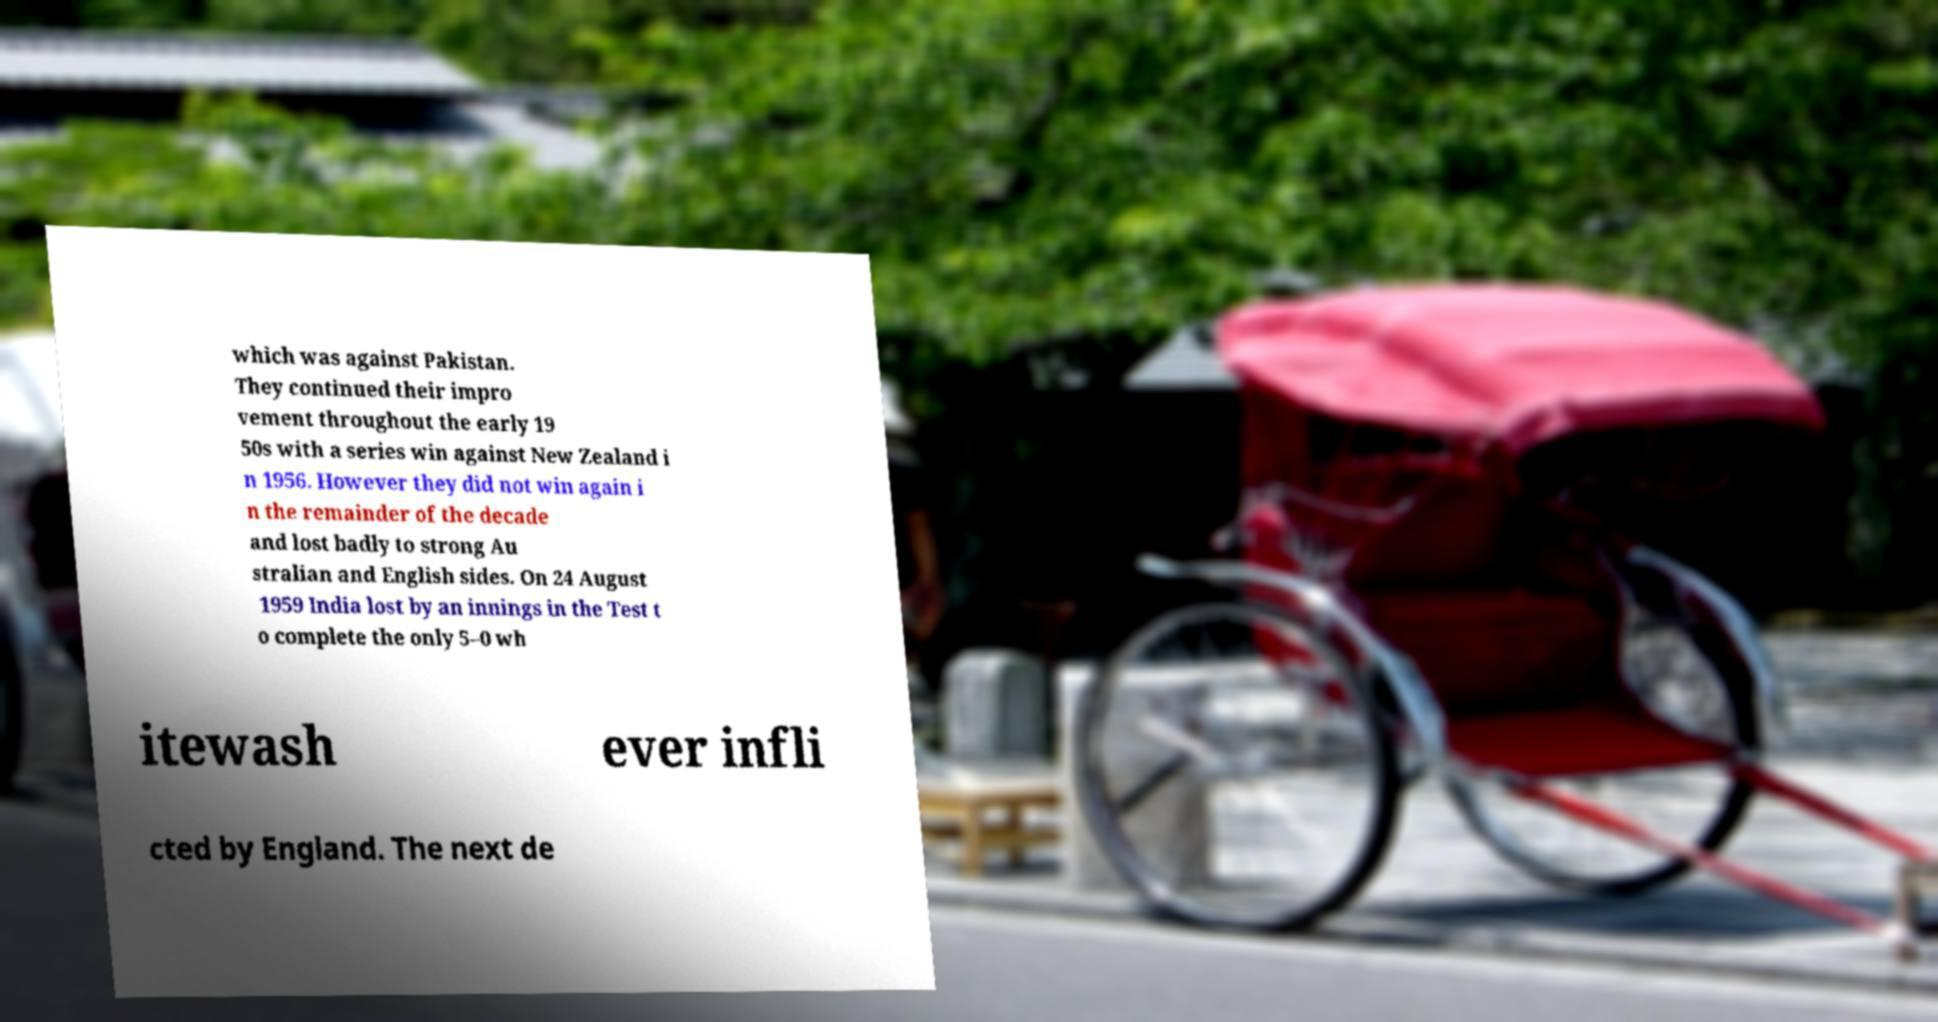Please read and relay the text visible in this image. What does it say? which was against Pakistan. They continued their impro vement throughout the early 19 50s with a series win against New Zealand i n 1956. However they did not win again i n the remainder of the decade and lost badly to strong Au stralian and English sides. On 24 August 1959 India lost by an innings in the Test t o complete the only 5–0 wh itewash ever infli cted by England. The next de 